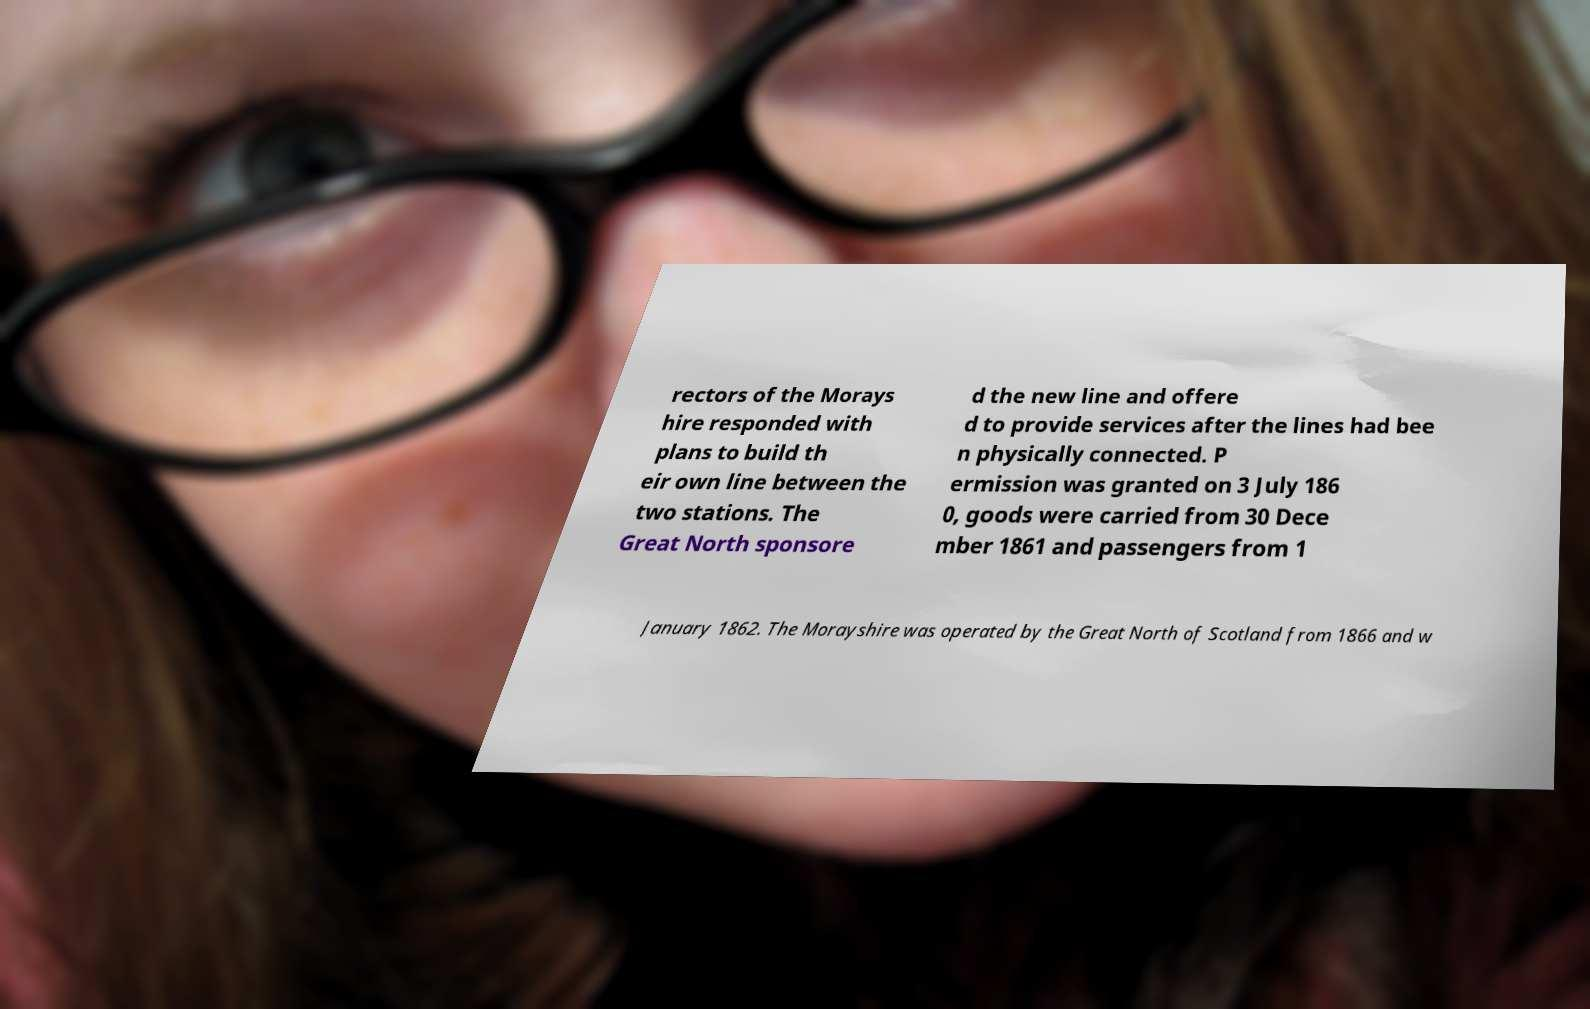What messages or text are displayed in this image? I need them in a readable, typed format. rectors of the Morays hire responded with plans to build th eir own line between the two stations. The Great North sponsore d the new line and offere d to provide services after the lines had bee n physically connected. P ermission was granted on 3 July 186 0, goods were carried from 30 Dece mber 1861 and passengers from 1 January 1862. The Morayshire was operated by the Great North of Scotland from 1866 and w 